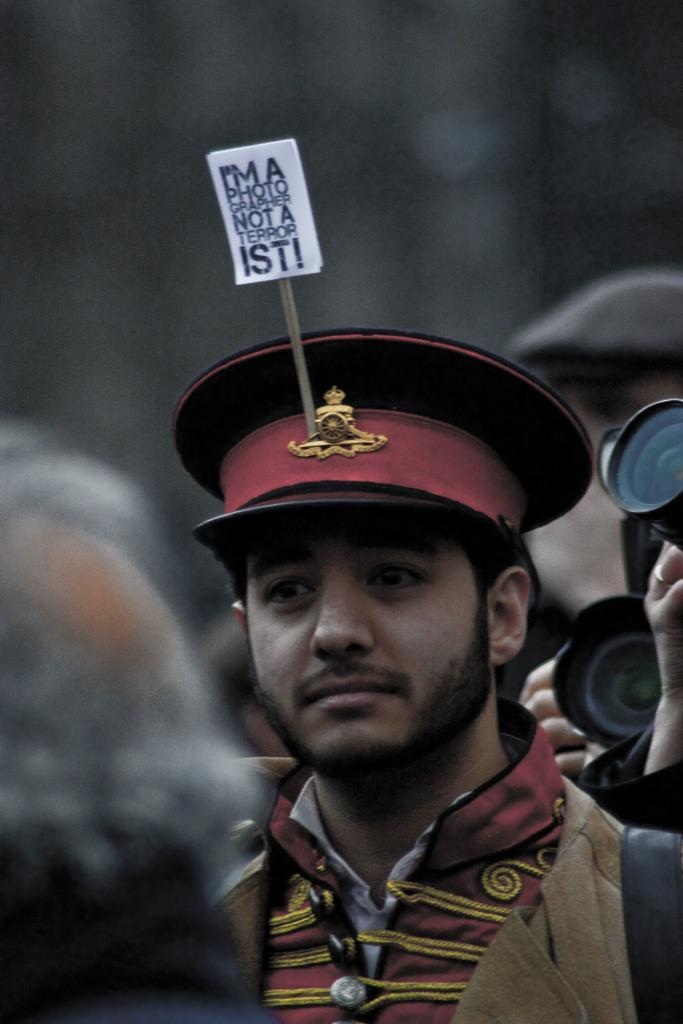Who is present in the image? There is a man in the image. What is the man wearing on his head? The man is wearing a cap. Is there any text or image on the cap? Yes, there is a placard on the cap. How many people are visible in the image? There are many people in the image. What type of rice is being cooked in the image? There is no rice present in the image. How many clocks can be seen hanging on the wall in the image? There are no clocks visible in the image. 